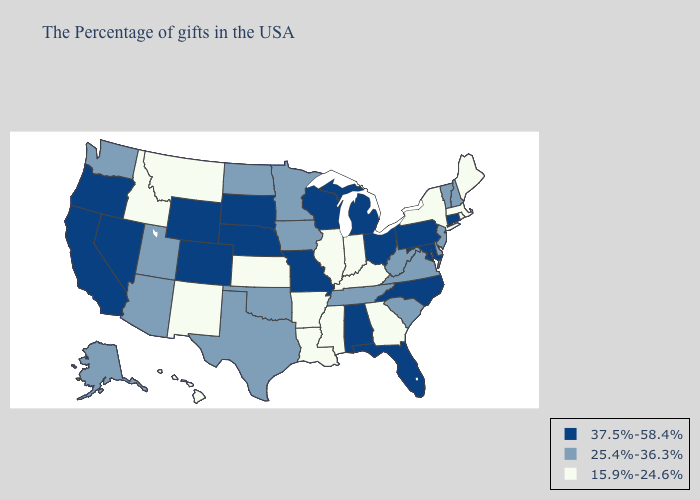Does Maine have the highest value in the Northeast?
Quick response, please. No. Does the first symbol in the legend represent the smallest category?
Give a very brief answer. No. Does Kentucky have the highest value in the USA?
Answer briefly. No. Among the states that border New Jersey , which have the highest value?
Give a very brief answer. Pennsylvania. Is the legend a continuous bar?
Short answer required. No. Among the states that border Kentucky , which have the lowest value?
Concise answer only. Indiana, Illinois. Does Wisconsin have the highest value in the MidWest?
Concise answer only. Yes. What is the lowest value in the USA?
Write a very short answer. 15.9%-24.6%. Which states have the highest value in the USA?
Answer briefly. Connecticut, Maryland, Pennsylvania, North Carolina, Ohio, Florida, Michigan, Alabama, Wisconsin, Missouri, Nebraska, South Dakota, Wyoming, Colorado, Nevada, California, Oregon. Among the states that border Tennessee , which have the lowest value?
Be succinct. Georgia, Kentucky, Mississippi, Arkansas. What is the value of Colorado?
Give a very brief answer. 37.5%-58.4%. Does Vermont have the highest value in the Northeast?
Be succinct. No. Does the first symbol in the legend represent the smallest category?
Answer briefly. No. Does Connecticut have a higher value than North Carolina?
Be succinct. No. What is the value of New Mexico?
Be succinct. 15.9%-24.6%. 